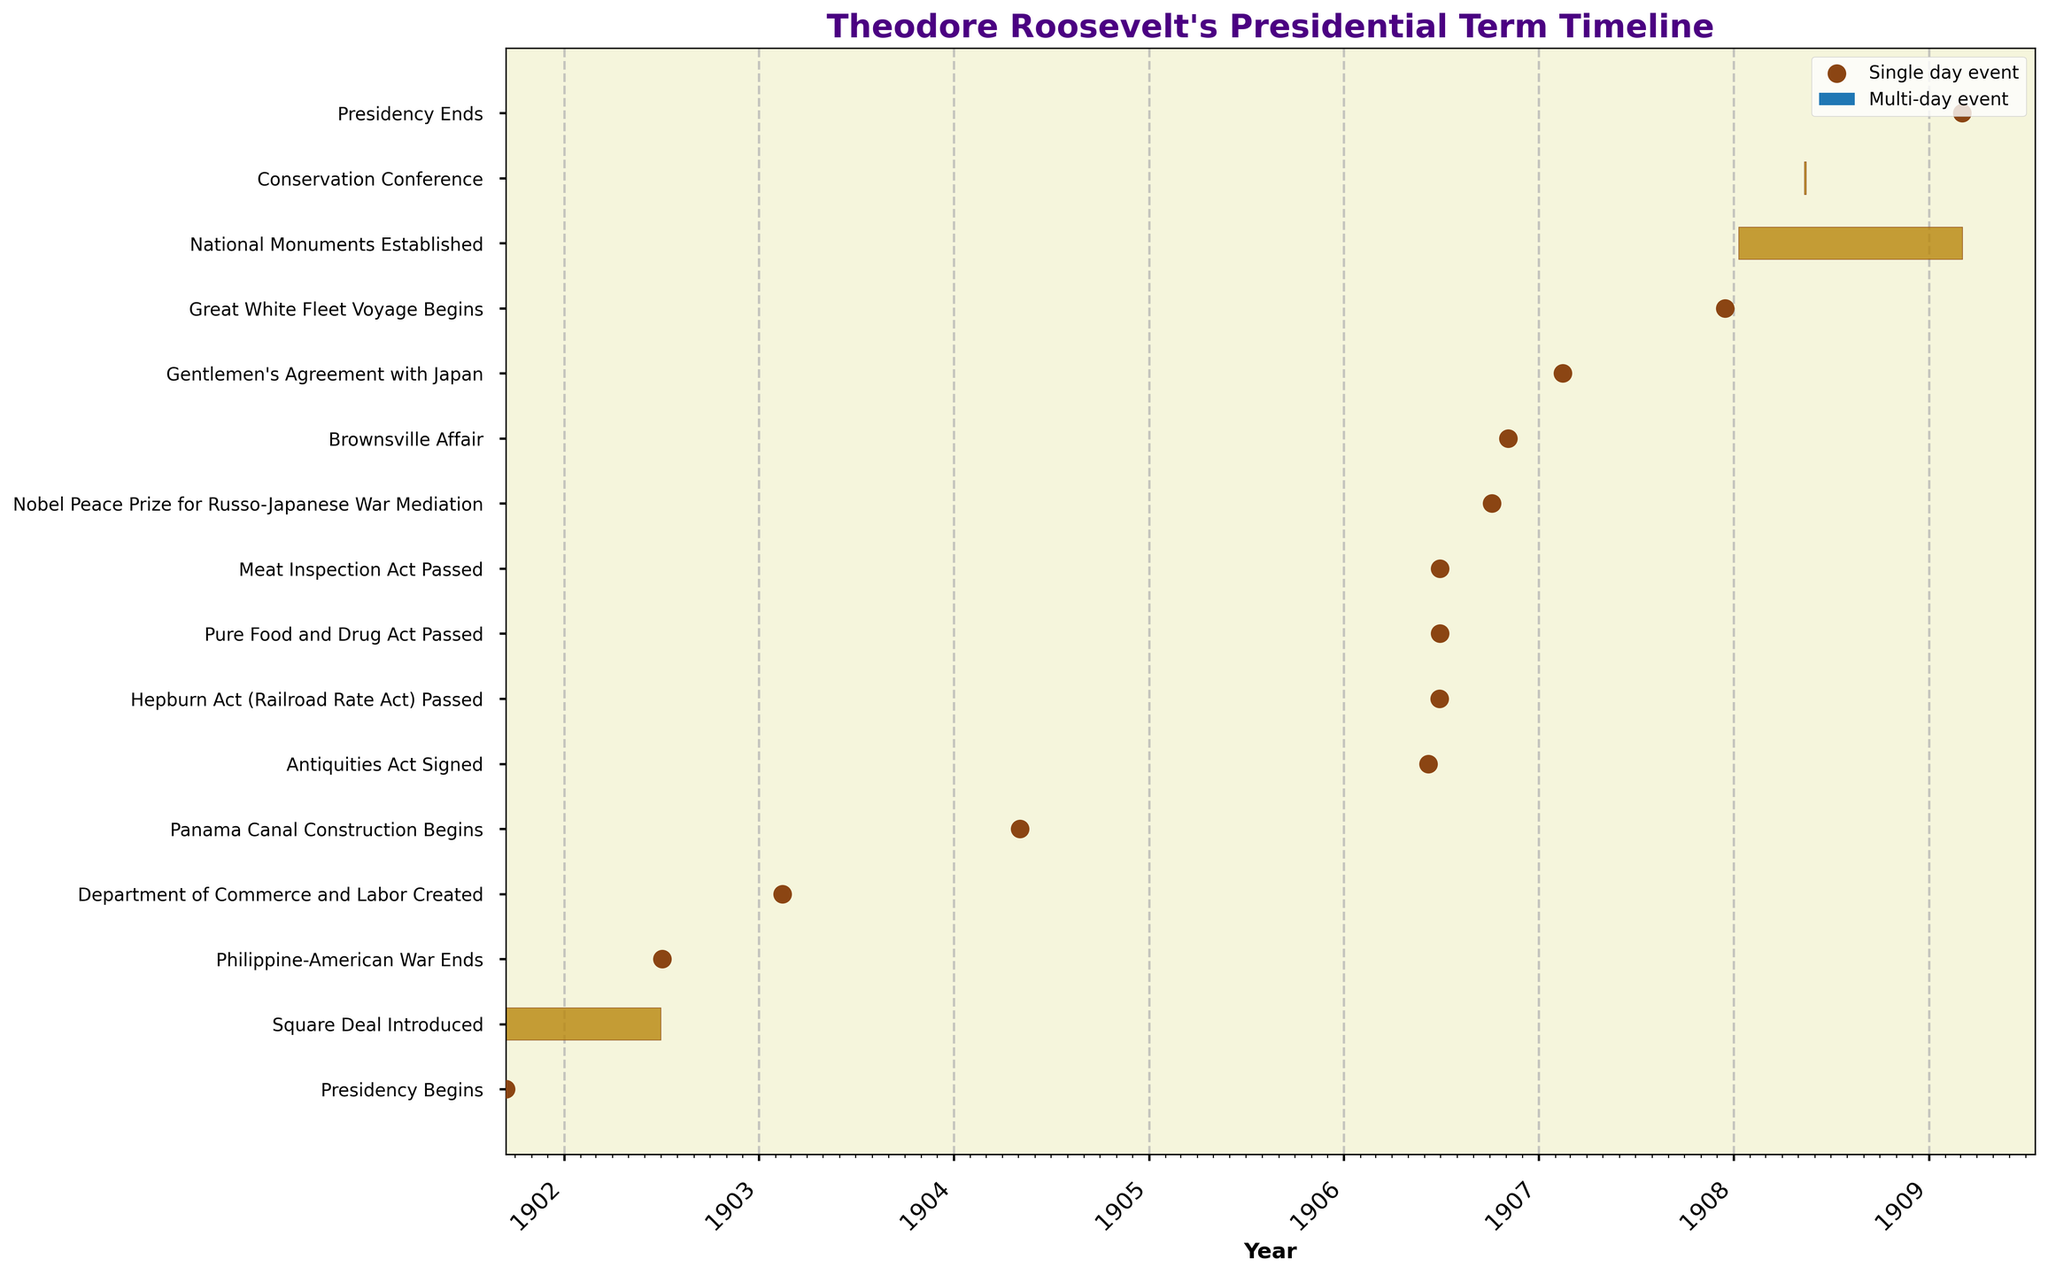When did Theodore Roosevelt's presidency begin? The title of the first task on the chart is "Presidency Begins," which indicates the start of his presidential term. This event is marked on the chart on September 14, 1901.
Answer: September 14, 1901 How many single-day events are indicated on the chart? Single-day events are visualized on the chart with scatter points. In the figure, one can count these scatter points to determine the number of single-day events.
Answer: 11 What significant event related to the Panama Canal is shown in the chart? The Gantt chart includes an event named "Panama Canal Construction Begins." This event is specifically marked and highlighted.
Answer: Panama Canal Construction Begins Which policy was introduced first: the 'Square Deal' or the 'Pure Food and Drug Act'? According to the chart's timeline, the 'Square Deal' was introduced just after Theodore Roosevelt's presidency began in September 1901, while the 'Pure Food and Drug Act' was passed on June 30, 1906. Therefore, the 'Square Deal' came first.
Answer: Square Deal Which event had the longest duration? Among the events listed, "National Monuments Established" spans the longest duration from January 11, 1908, to March 4, 1909. This period is marked with a horizontal bar covering the longest span on the Gantt chart.
Answer: National Monuments Established How does the timeline of the 'Square Deal' compare to that of the 'Nobel Peace Prize'? The 'Square Deal' is shown to have begun on September 14, 1901, and ended on June 30, 1902. In comparison, the 'Nobel Peace Prize' was awarded on October 5, 1906. The 'Square Deal' was an ongoing policy achievement that concluded long before the awarding of the Nobel Peace Prize to Theodore Roosevelt.
Answer: 'Square Deal' ended before 'Nobel Peace Prize' In what year did the 'Great White Fleet Voyage' begin? The chart shows a specific event marked as the 'Great White Fleet Voyage Begins,' which is indicated in December 1907.
Answer: 1907 How many events are depicted to have occurred in 1906? By reviewing the chart, it becomes clear that multiple events in the year 1906. Specifically, the events 'Nobel Peace Prize for Russo-Japanese War Mediation,' 'Pure Food and Drug Act Passed,' 'Meat Inspection Act Passed,' 'Antiquities Act Signed,' 'Hepburn Act (Railroad Rate Act) Passed,' and the 'Brownsville Affair' all happened in 1906. Counting these totals to six events in that year.
Answer: 6 Which lasted longer: the 'Square Deal' introduction or the 'Antiquities Act' establishment? The timeline for the 'Square Deal' introduction spans from September 14, 1901, to June 30, 1902. This is almost ten months long. Comparatively, the 'Antiquities Act' was signed on a single day, June 8, 1906. Thus, the 'Square Deal' lasted much longer.
Answer: Square Deal What event marks the end of Theodore Roosevelt's presidency? The final event on the Gantt chart is labeled 'Presidency Ends,' which indicates the cessation of Theodore Roosevelt's time in office on March 4, 1909.
Answer: March 4, 1909 